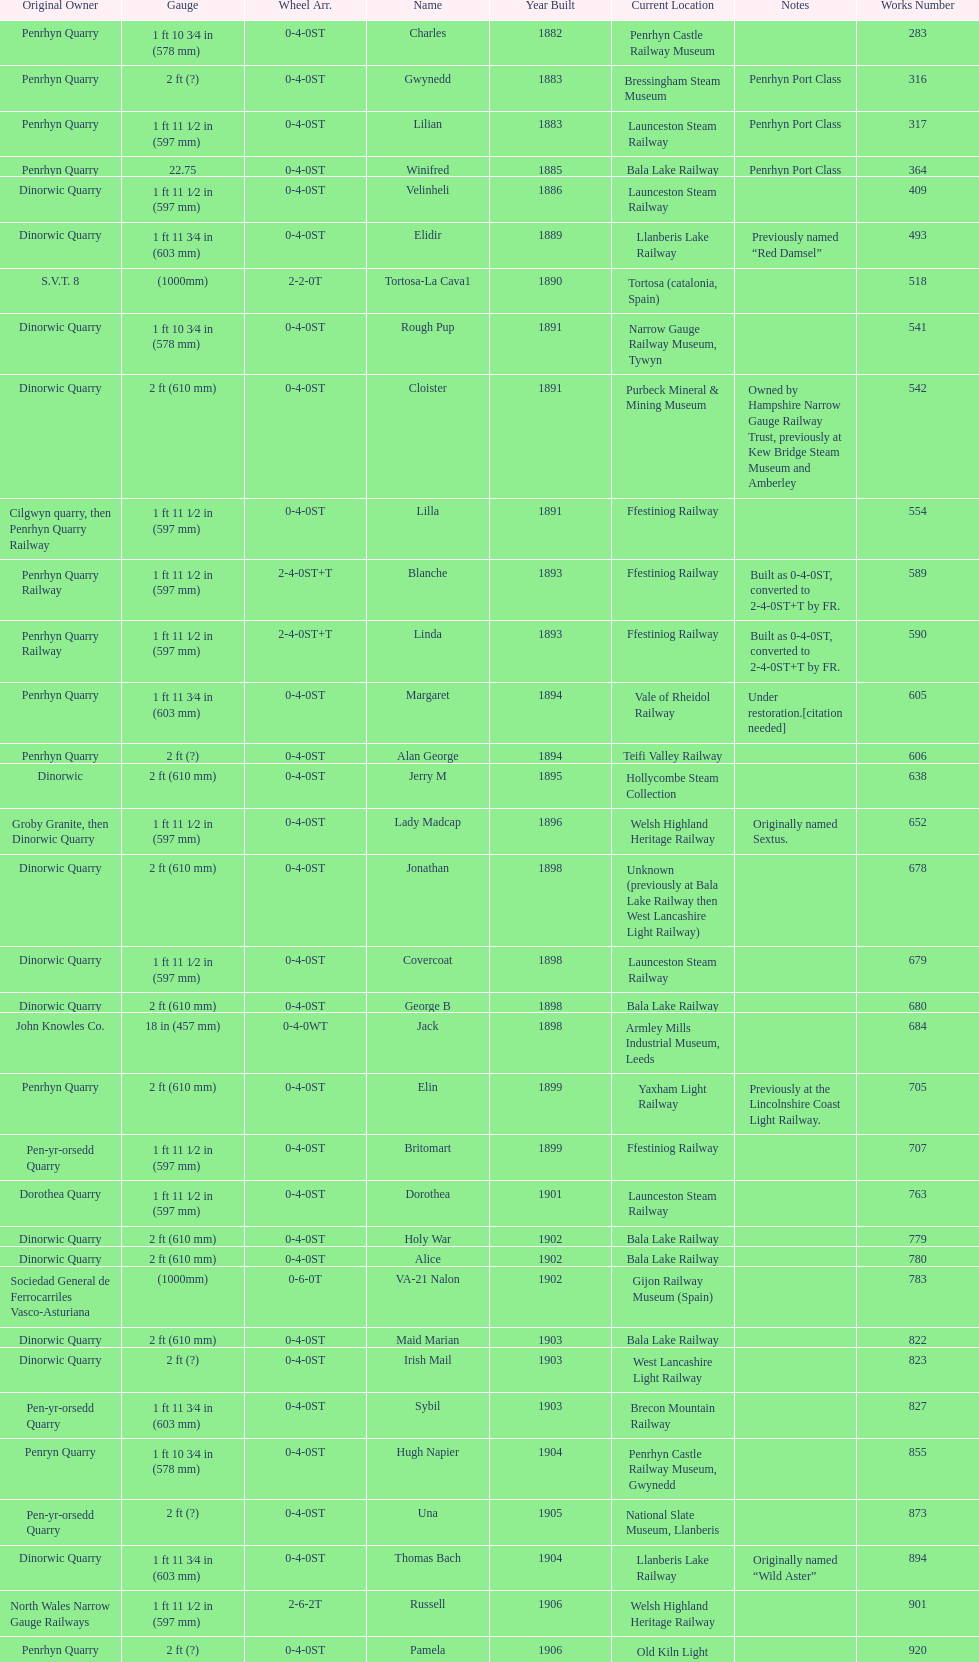What is the difference in gauge between works numbers 541 and 542? 32 mm. 